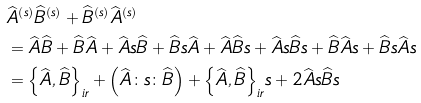<formula> <loc_0><loc_0><loc_500><loc_500>& { { \widehat { A } } ^ { \left ( s \right ) } } { { \widehat { B } } ^ { \left ( s \right ) } } + { { \widehat { B } } ^ { \left ( s \right ) } } { { \widehat { A } } ^ { \left ( s \right ) } } \\ & = \widehat { A } \widehat { B } + \widehat { B } \widehat { A } + \widehat { A } s \widehat { B } + \widehat { B } s \widehat { A } + \widehat { A } \widehat { B } s + \widehat { A } s \widehat { B } s + \widehat { B } \widehat { A } s + \widehat { B } s \widehat { A } s \\ & = { { \left \{ \widehat { A } , \widehat { B } \right \} } _ { i r } } + \left ( \widehat { A } \colon s \colon \widehat { B } \right ) + { { \left \{ \widehat { A } , \widehat { B } \right \} } _ { i r } } s + 2 \widehat { A } s \widehat { B } s</formula> 